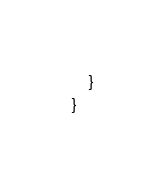Convert code to text. <code><loc_0><loc_0><loc_500><loc_500><_C#_>
    }
}</code> 